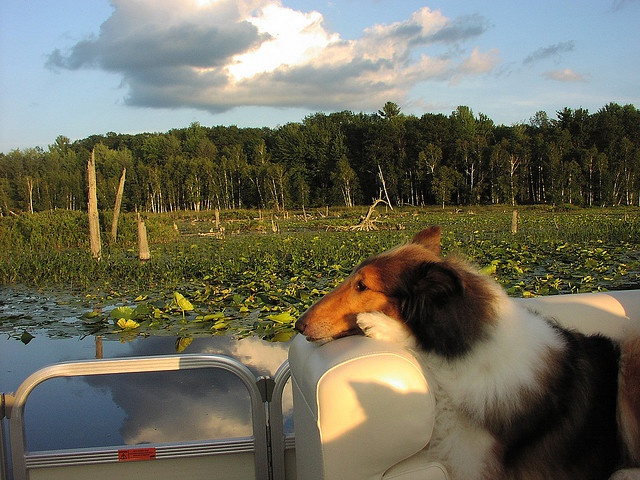Describe the objects in this image and their specific colors. I can see a dog in lightblue, black, gray, and maroon tones in this image. 